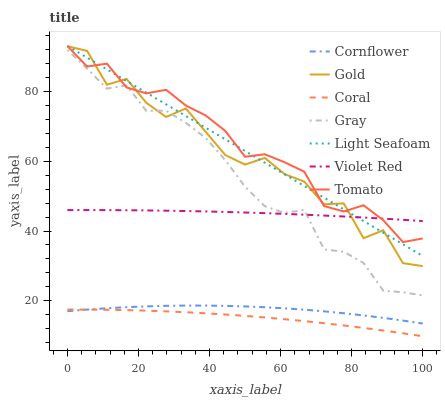Does Coral have the minimum area under the curve?
Answer yes or no. Yes. Does Tomato have the maximum area under the curve?
Answer yes or no. Yes. Does Cornflower have the minimum area under the curve?
Answer yes or no. No. Does Cornflower have the maximum area under the curve?
Answer yes or no. No. Is Light Seafoam the smoothest?
Answer yes or no. Yes. Is Gold the roughest?
Answer yes or no. Yes. Is Cornflower the smoothest?
Answer yes or no. No. Is Cornflower the roughest?
Answer yes or no. No. Does Cornflower have the lowest value?
Answer yes or no. No. Does Cornflower have the highest value?
Answer yes or no. No. Is Coral less than Violet Red?
Answer yes or no. Yes. Is Violet Red greater than Coral?
Answer yes or no. Yes. Does Coral intersect Violet Red?
Answer yes or no. No. 